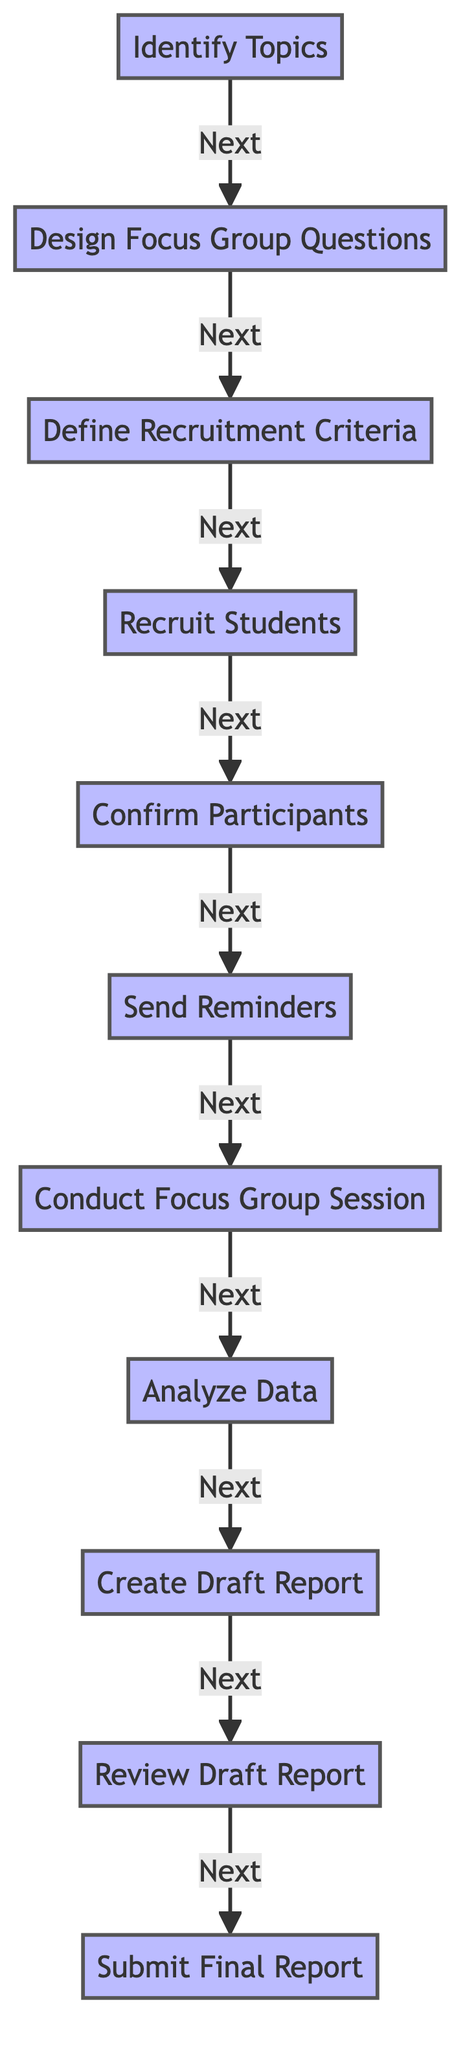what's the last step in the workflow? The last step in the workflow is represented by the node named "Submit Final Report". It indicates the final action to complete the focus group organization process.
Answer: Submit Final Report how many processes are involved in the workflow? Counting each distinct process represented in the diagram, there are eleven processes that collectively outline the entire workflow from start to finish.
Answer: 11 which step follows "Recruit Students"? The flowchart indicates that "Confirm Participants" is the next step that follows after "Recruit Students". The arrows in the diagram show this direct progression.
Answer: Confirm Participants what is the purpose of the "Analyze Data" step? "Analyze Data" is the step where the feedback and data collected from the focus group sessions are examined and interpreted to formulate conclusions. This is essential for creating a comprehensive draft report.
Answer: Analyze feedback and data which process happens immediately before reviewing the draft report? The process that occurs immediately before "Review Draft Report" is "Create Draft Report". The directional flow of arrows in the diagram illustrates this sequence clearly.
Answer: Create Draft Report what is the starting point of this workflow? The workflow initiates with the "Identify Topics" step, which sets the foundation for the subsequent actions related to organizing the focus group.
Answer: Identify Topics which step in the workflow involves participant engagement? The step that directly involves participant interaction is "Conduct Focus Group Session", where students provide their feedback during the organized discussion, gathering insights directly from them.
Answer: Conduct Focus Group Session how does participant confirmation relate to the reminder sending? The workflow shows that "Confirm Participants" precedes "Send Reminders". This means that confirming participant attendance is necessary before sending reminders.
Answer: Confirmation precedes reminders what is the action taken after drafting the report? Following the "Create Draft Report", the next action is the "Review Draft Report". This indicates a quality check before finalizing the outcome of the focus group session.
Answer: Review Draft Report 